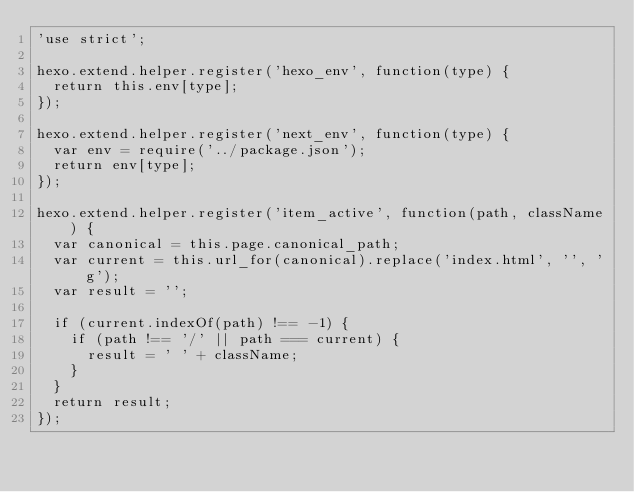Convert code to text. <code><loc_0><loc_0><loc_500><loc_500><_JavaScript_>'use strict';

hexo.extend.helper.register('hexo_env', function(type) {
  return this.env[type];
});

hexo.extend.helper.register('next_env', function(type) {
  var env = require('../package.json');
  return env[type];
});

hexo.extend.helper.register('item_active', function(path, className) {
  var canonical = this.page.canonical_path;
  var current = this.url_for(canonical).replace('index.html', '', 'g');
  var result = '';

  if (current.indexOf(path) !== -1) {
    if (path !== '/' || path === current) {
      result = ' ' + className;
    }
  }
  return result;
});
</code> 